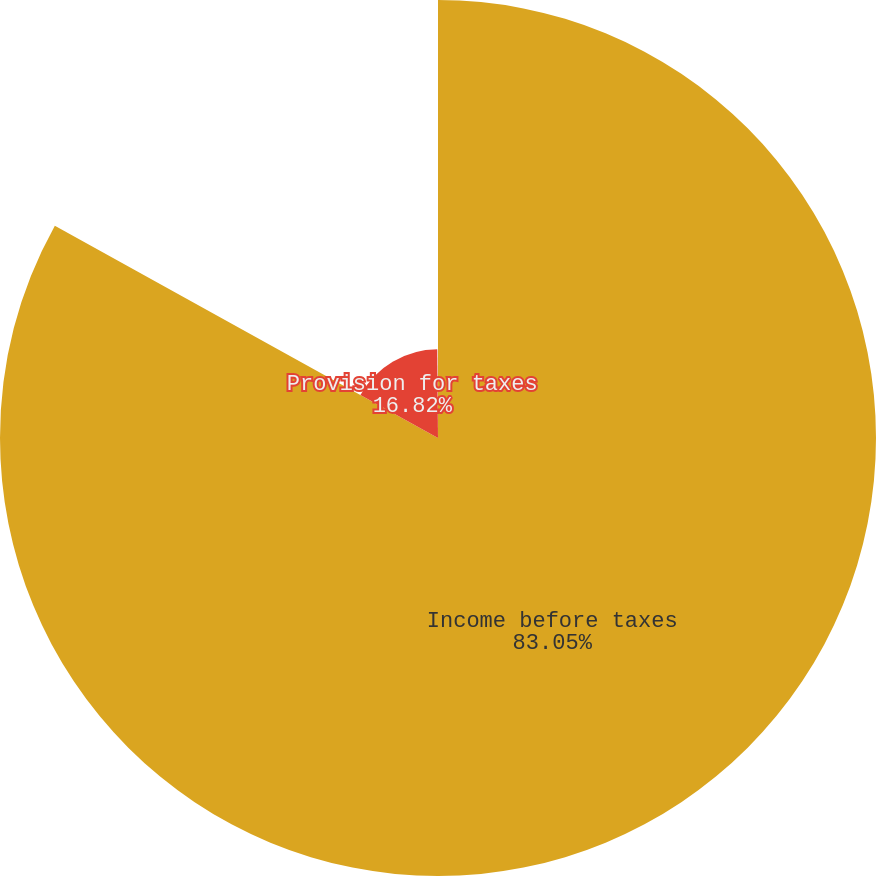Convert chart. <chart><loc_0><loc_0><loc_500><loc_500><pie_chart><fcel>Income before taxes<fcel>Provision for taxes<fcel>Effective tax rate<nl><fcel>83.05%<fcel>16.82%<fcel>0.13%<nl></chart> 